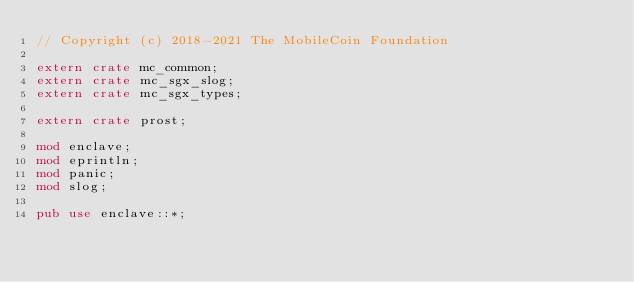Convert code to text. <code><loc_0><loc_0><loc_500><loc_500><_Rust_>// Copyright (c) 2018-2021 The MobileCoin Foundation

extern crate mc_common;
extern crate mc_sgx_slog;
extern crate mc_sgx_types;

extern crate prost;

mod enclave;
mod eprintln;
mod panic;
mod slog;

pub use enclave::*;
</code> 